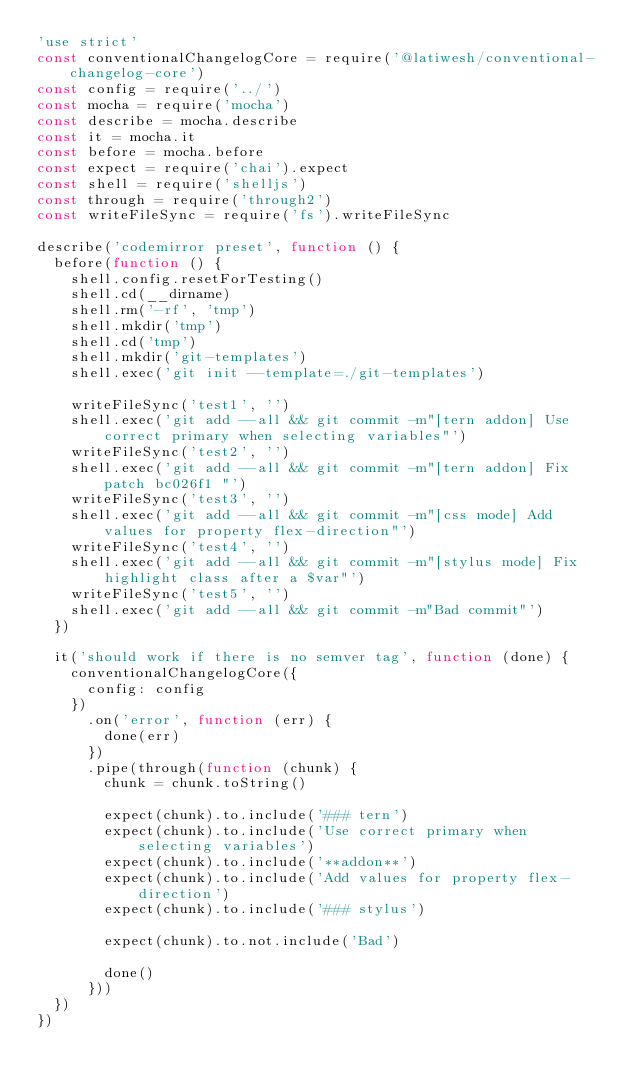<code> <loc_0><loc_0><loc_500><loc_500><_JavaScript_>'use strict'
const conventionalChangelogCore = require('@latiwesh/conventional-changelog-core')
const config = require('../')
const mocha = require('mocha')
const describe = mocha.describe
const it = mocha.it
const before = mocha.before
const expect = require('chai').expect
const shell = require('shelljs')
const through = require('through2')
const writeFileSync = require('fs').writeFileSync

describe('codemirror preset', function () {
  before(function () {
    shell.config.resetForTesting()
    shell.cd(__dirname)
    shell.rm('-rf', 'tmp')
    shell.mkdir('tmp')
    shell.cd('tmp')
    shell.mkdir('git-templates')
    shell.exec('git init --template=./git-templates')

    writeFileSync('test1', '')
    shell.exec('git add --all && git commit -m"[tern addon] Use correct primary when selecting variables"')
    writeFileSync('test2', '')
    shell.exec('git add --all && git commit -m"[tern addon] Fix patch bc026f1 "')
    writeFileSync('test3', '')
    shell.exec('git add --all && git commit -m"[css mode] Add values for property flex-direction"')
    writeFileSync('test4', '')
    shell.exec('git add --all && git commit -m"[stylus mode] Fix highlight class after a $var"')
    writeFileSync('test5', '')
    shell.exec('git add --all && git commit -m"Bad commit"')
  })

  it('should work if there is no semver tag', function (done) {
    conventionalChangelogCore({
      config: config
    })
      .on('error', function (err) {
        done(err)
      })
      .pipe(through(function (chunk) {
        chunk = chunk.toString()

        expect(chunk).to.include('### tern')
        expect(chunk).to.include('Use correct primary when selecting variables')
        expect(chunk).to.include('**addon**')
        expect(chunk).to.include('Add values for property flex-direction')
        expect(chunk).to.include('### stylus')

        expect(chunk).to.not.include('Bad')

        done()
      }))
  })
})
</code> 